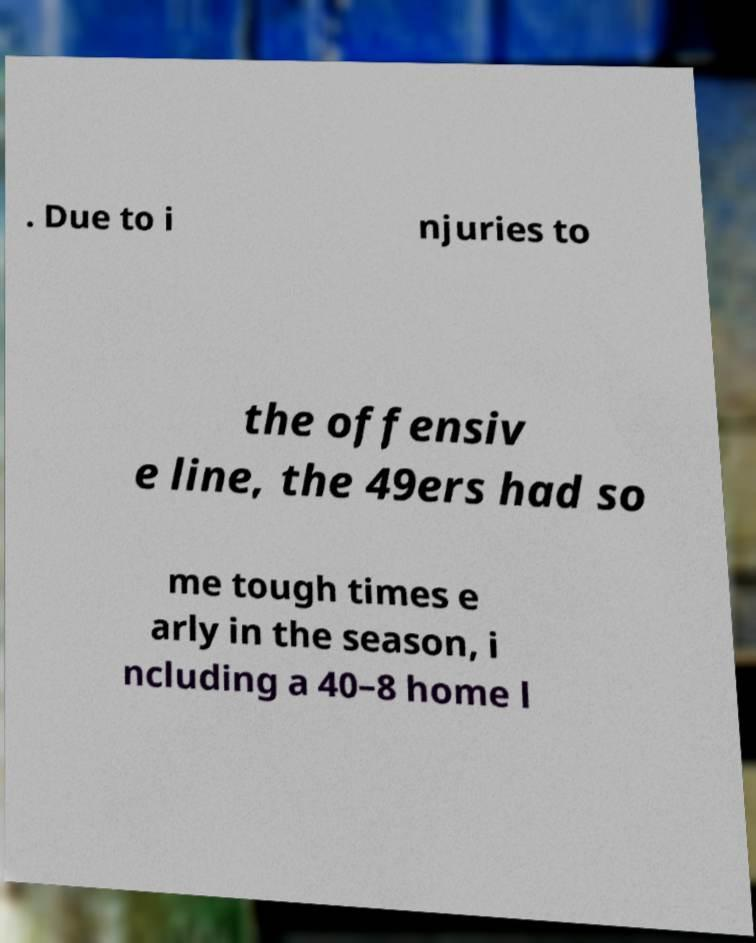I need the written content from this picture converted into text. Can you do that? . Due to i njuries to the offensiv e line, the 49ers had so me tough times e arly in the season, i ncluding a 40–8 home l 